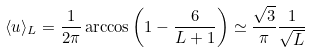Convert formula to latex. <formula><loc_0><loc_0><loc_500><loc_500>\langle u \rangle _ { L } = \frac { 1 } { 2 \pi } \arccos \left ( 1 - \frac { 6 } { L + 1 } \right ) \simeq \frac { \sqrt { 3 } } { \pi } \frac { 1 } { \sqrt { L } }</formula> 